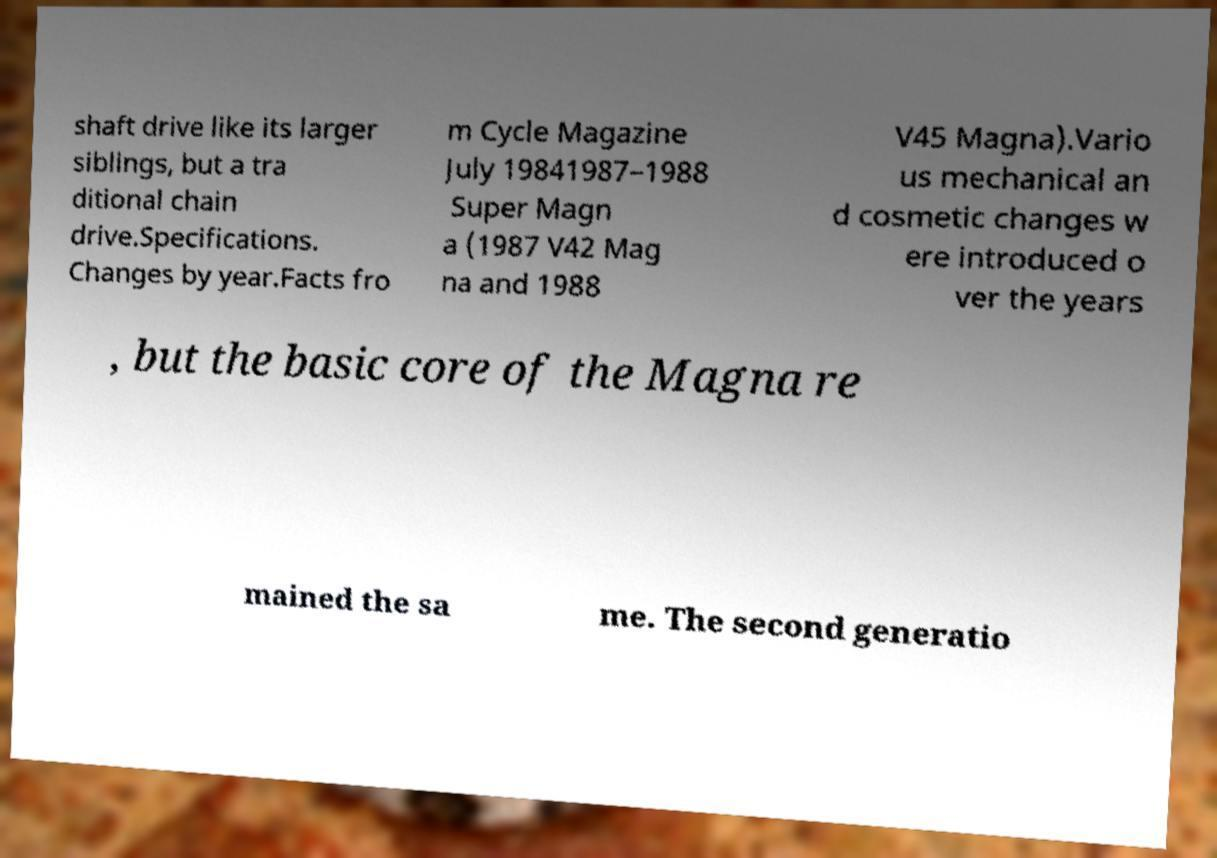Please read and relay the text visible in this image. What does it say? shaft drive like its larger siblings, but a tra ditional chain drive.Specifications. Changes by year.Facts fro m Cycle Magazine July 19841987–1988 Super Magn a (1987 V42 Mag na and 1988 V45 Magna).Vario us mechanical an d cosmetic changes w ere introduced o ver the years , but the basic core of the Magna re mained the sa me. The second generatio 